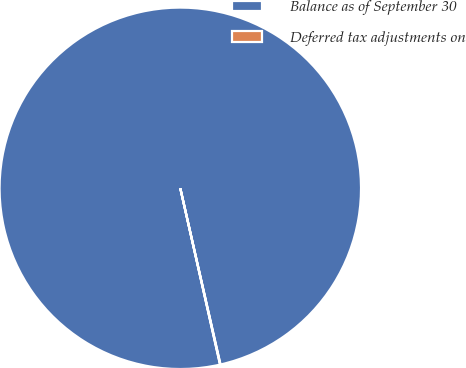Convert chart to OTSL. <chart><loc_0><loc_0><loc_500><loc_500><pie_chart><fcel>Balance as of September 30<fcel>Deferred tax adjustments on<nl><fcel>99.96%<fcel>0.04%<nl></chart> 